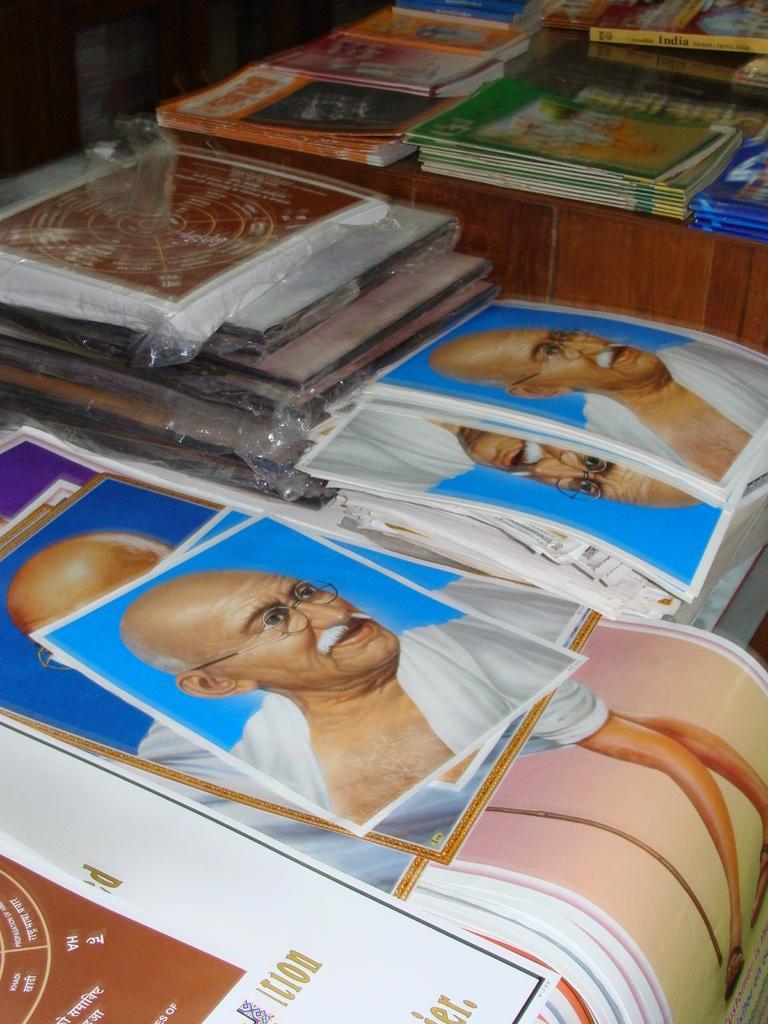In one or two sentences, can you explain what this image depicts? These are the posters with the picture of Mahatma Gandhi and the books, which are placed on the wooden table. 